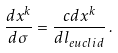Convert formula to latex. <formula><loc_0><loc_0><loc_500><loc_500>\frac { d x ^ { k } } { d \sigma } = \frac { c d x ^ { k } } { d l _ { e u c l i d } } \, .</formula> 